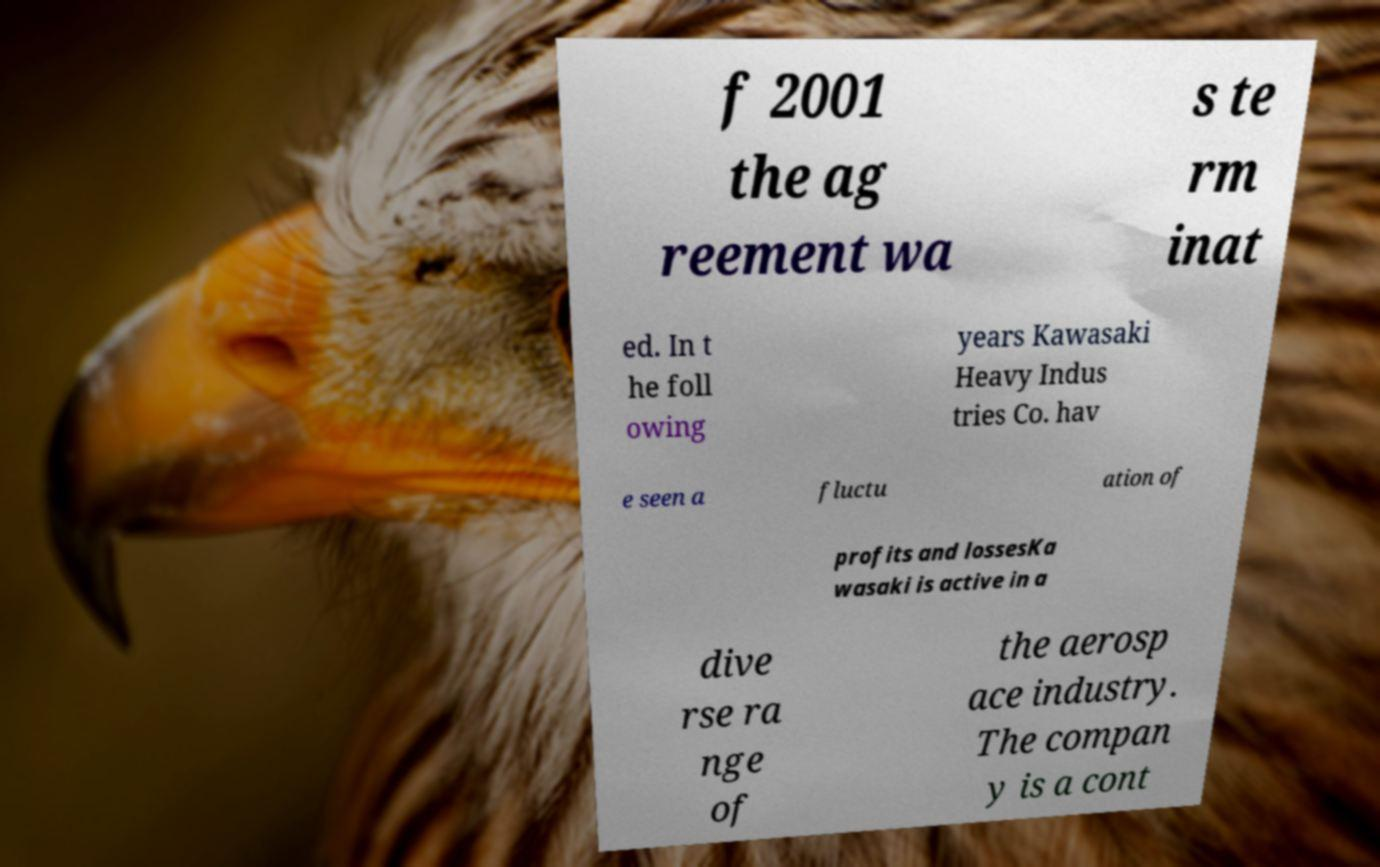Please read and relay the text visible in this image. What does it say? f 2001 the ag reement wa s te rm inat ed. In t he foll owing years Kawasaki Heavy Indus tries Co. hav e seen a fluctu ation of profits and lossesKa wasaki is active in a dive rse ra nge of the aerosp ace industry. The compan y is a cont 